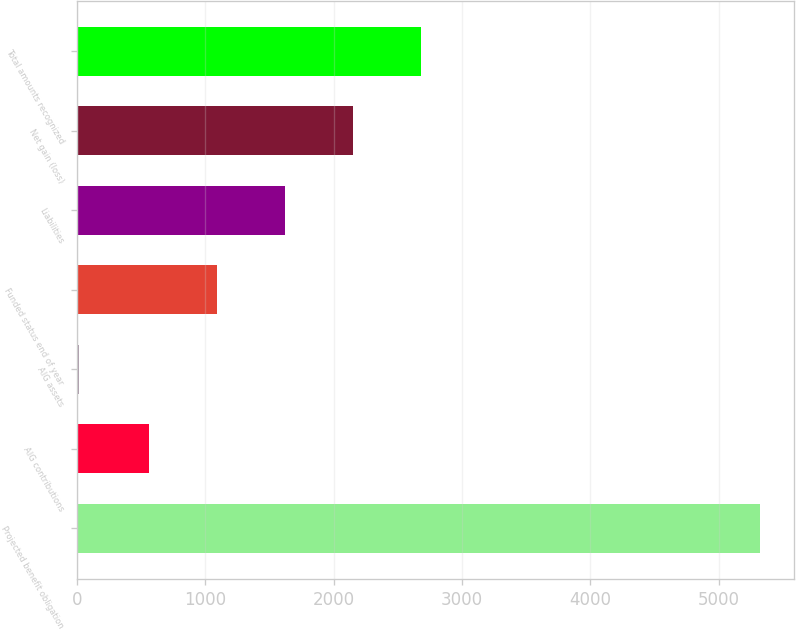<chart> <loc_0><loc_0><loc_500><loc_500><bar_chart><fcel>Projected benefit obligation<fcel>AIG contributions<fcel>AIG assets<fcel>Funded status end of year<fcel>Liabilities<fcel>Net gain (loss)<fcel>Total amounts recognized<nl><fcel>5324<fcel>558<fcel>17<fcel>1088.7<fcel>1619.4<fcel>2150.1<fcel>2680.8<nl></chart> 